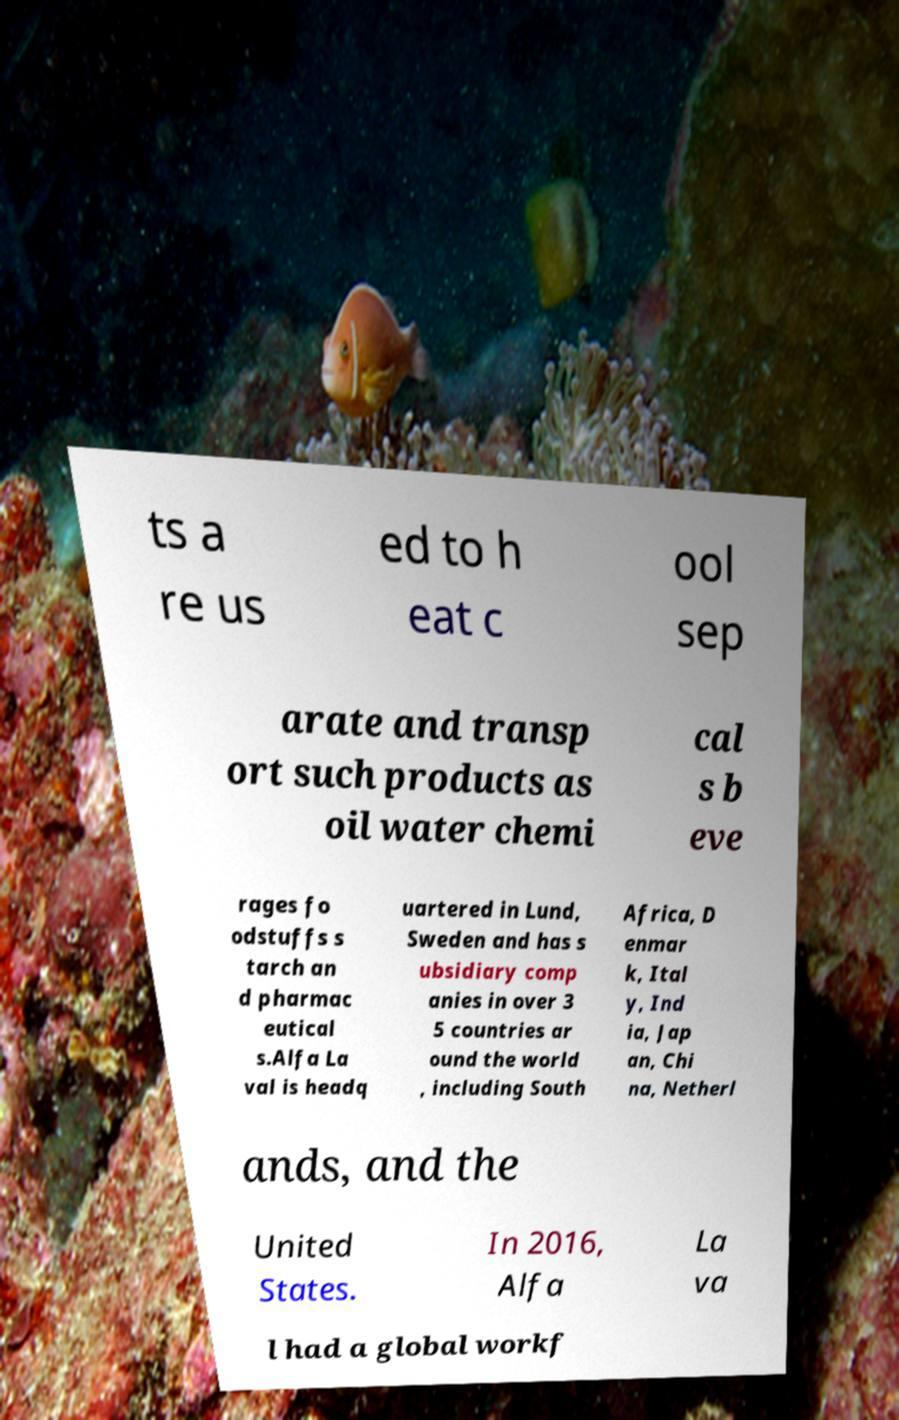Please identify and transcribe the text found in this image. ts a re us ed to h eat c ool sep arate and transp ort such products as oil water chemi cal s b eve rages fo odstuffs s tarch an d pharmac eutical s.Alfa La val is headq uartered in Lund, Sweden and has s ubsidiary comp anies in over 3 5 countries ar ound the world , including South Africa, D enmar k, Ital y, Ind ia, Jap an, Chi na, Netherl ands, and the United States. In 2016, Alfa La va l had a global workf 